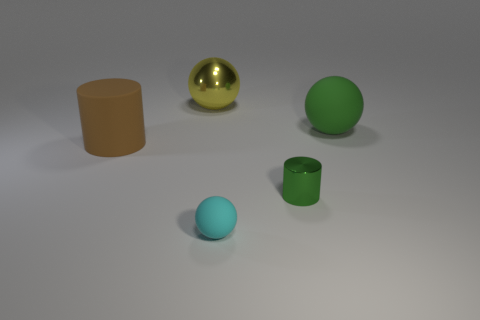What time of day does the lighting suggest? The lighting in the image is diffuse and non-directional, which suggests an indoor setting with artificial lighting rather than natural light. There are soft shadows under the objects indicating a source of light from above, possibly simulating what you would experience under an overcast sky or in a room lit by ambient lighting, devoid of any harsh direct light sources. 